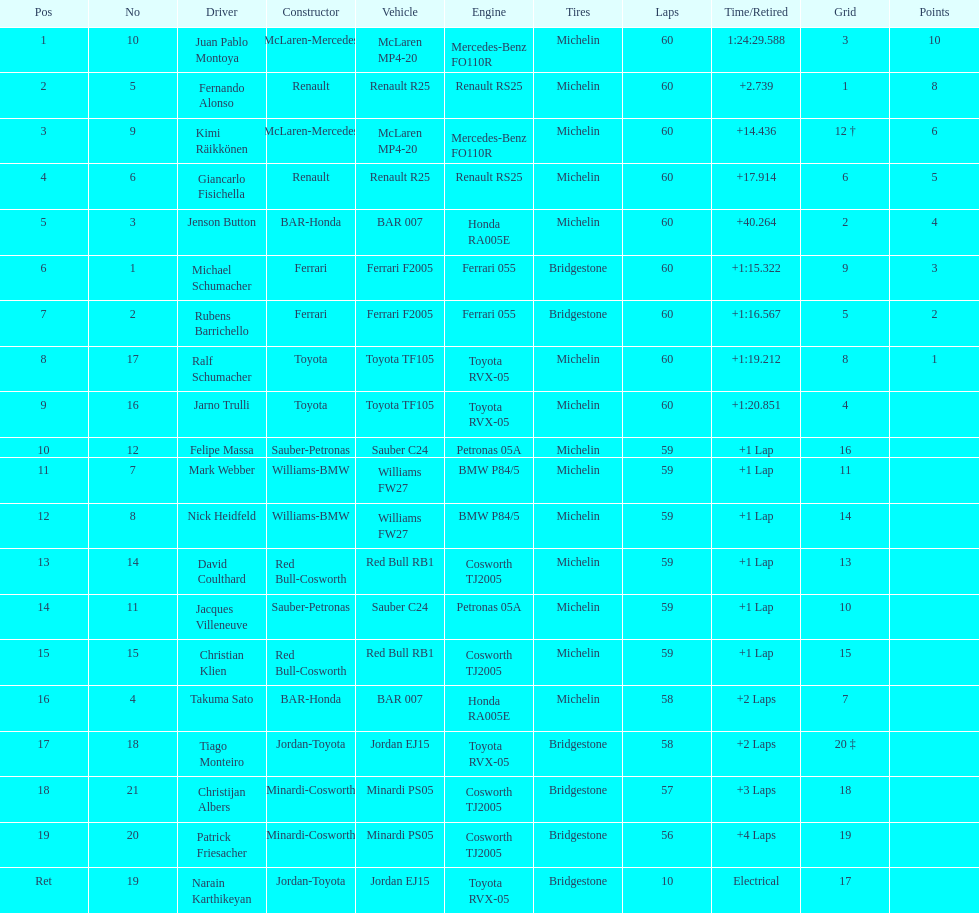Which driver has the least amount of points? Ralf Schumacher. 